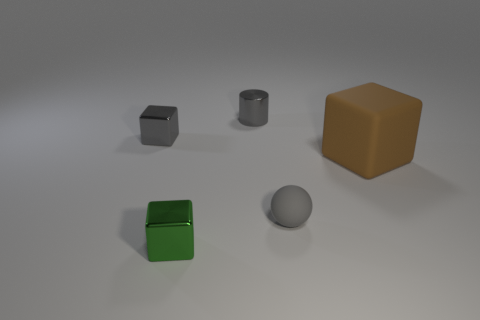How many objects are either gray metal things left of the green metallic cube or small gray rubber objects?
Make the answer very short. 2. There is a cube to the right of the small metal object that is in front of the small gray metal thing in front of the small metal cylinder; how big is it?
Offer a very short reply. Large. What is the material of the cube that is the same color as the small rubber object?
Your answer should be compact. Metal. Is there anything else that has the same shape as the small green object?
Offer a very short reply. Yes. There is a gray thing in front of the tiny shiny cube behind the large brown matte block; what is its size?
Ensure brevity in your answer.  Small. How many large things are either yellow matte objects or gray matte things?
Your response must be concise. 0. Is the number of green metallic blocks less than the number of blue metallic blocks?
Provide a short and direct response. No. Is there any other thing that is the same size as the green metal thing?
Your response must be concise. Yes. Does the small shiny cylinder have the same color as the tiny rubber object?
Your response must be concise. Yes. Are there more tiny rubber cylinders than tiny green metal things?
Keep it short and to the point. No. 